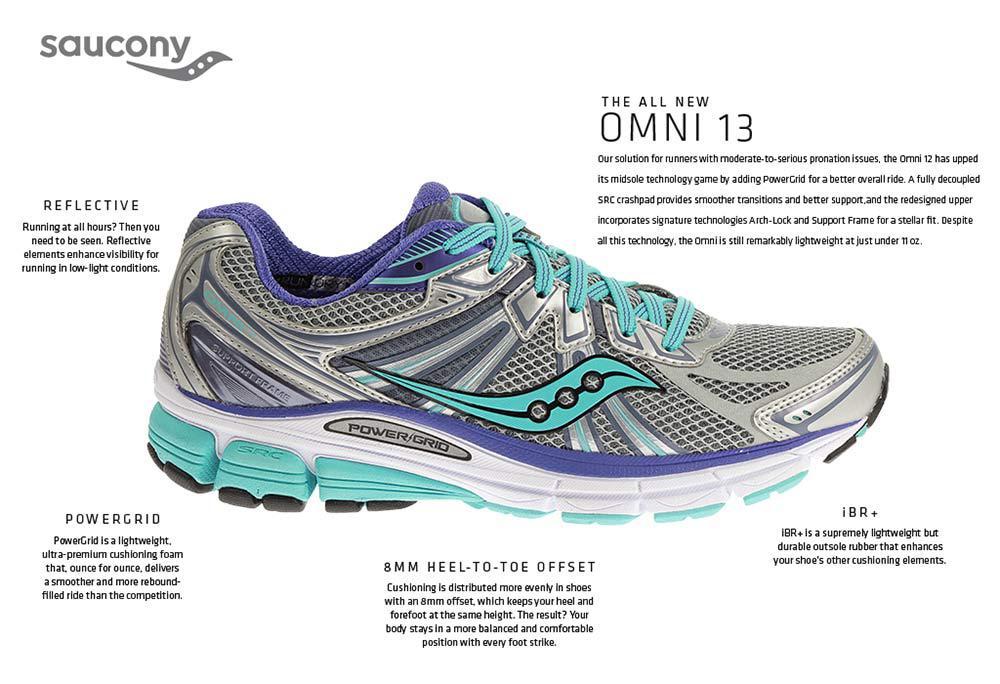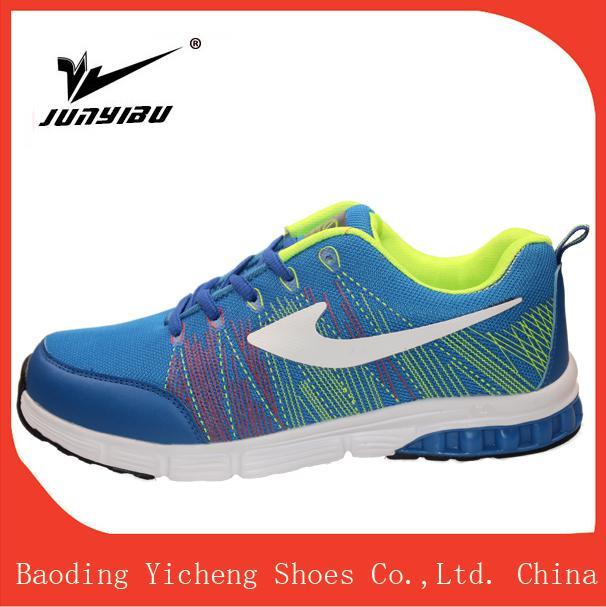The first image is the image on the left, the second image is the image on the right. Evaluate the accuracy of this statement regarding the images: "The shoes in each of the images have their toes facing the right.". Is it true? Answer yes or no. No. The first image is the image on the left, the second image is the image on the right. For the images shown, is this caption "Each image shows a single rightward-facing sneaker, and the combined images include lime green and aqua-blue colors, among others." true? Answer yes or no. No. 